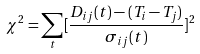<formula> <loc_0><loc_0><loc_500><loc_500>\chi ^ { 2 } = \sum _ { t } [ \frac { D _ { i j } ( t ) - ( T _ { i } - T _ { j } ) } { \sigma _ { i j } ( t ) } ] ^ { 2 }</formula> 